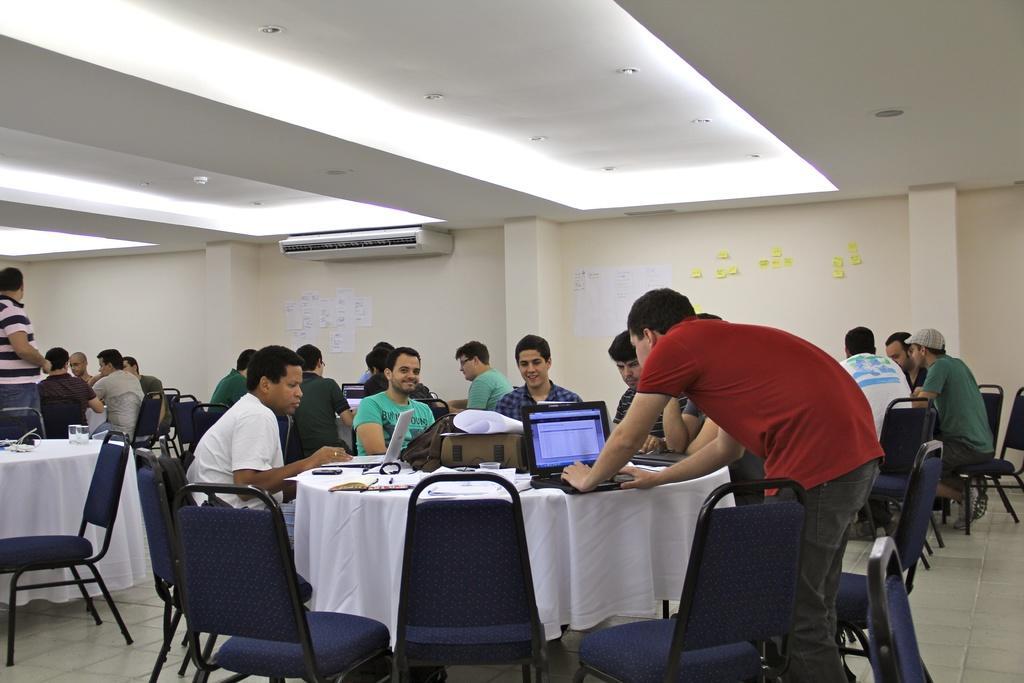Describe this image in one or two sentences. In this image I can see number of people, chairs and tables. In the background I can see sticky notes on this wall. 